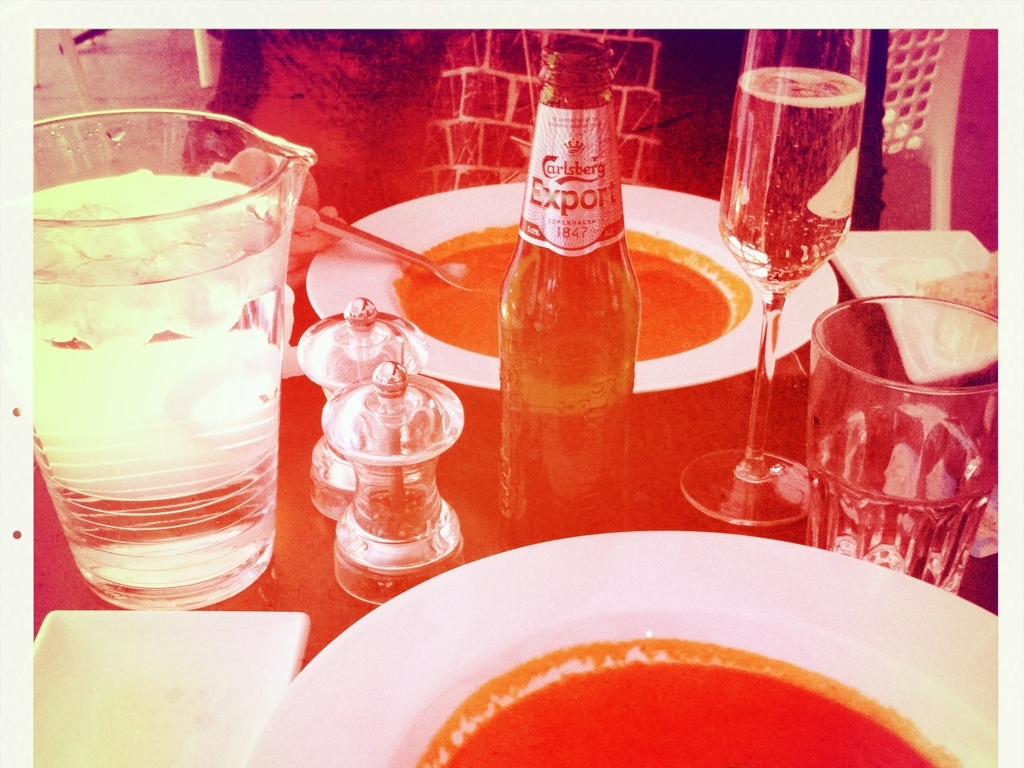What can we infer about the setting from this image? The setting appears to be a restaurant, given the presence of multiple tableware items and a commercial beer bottle. The sophistication of the items, like the champagne glass and the composition of the meal, suggests it might be a mid-to-high-end dining establishment. The choice of drink also indicates an adult audience. Is there anything unique about the table setup? Yes, the table setup includes a clear glass salt shaker in a classic design, which could imply attention to aesthetic details by the restaurant. The inclusion of both bread and alcohol with the soup suggests a thoughtful pairing by the establishment to enhance the dining experience. 